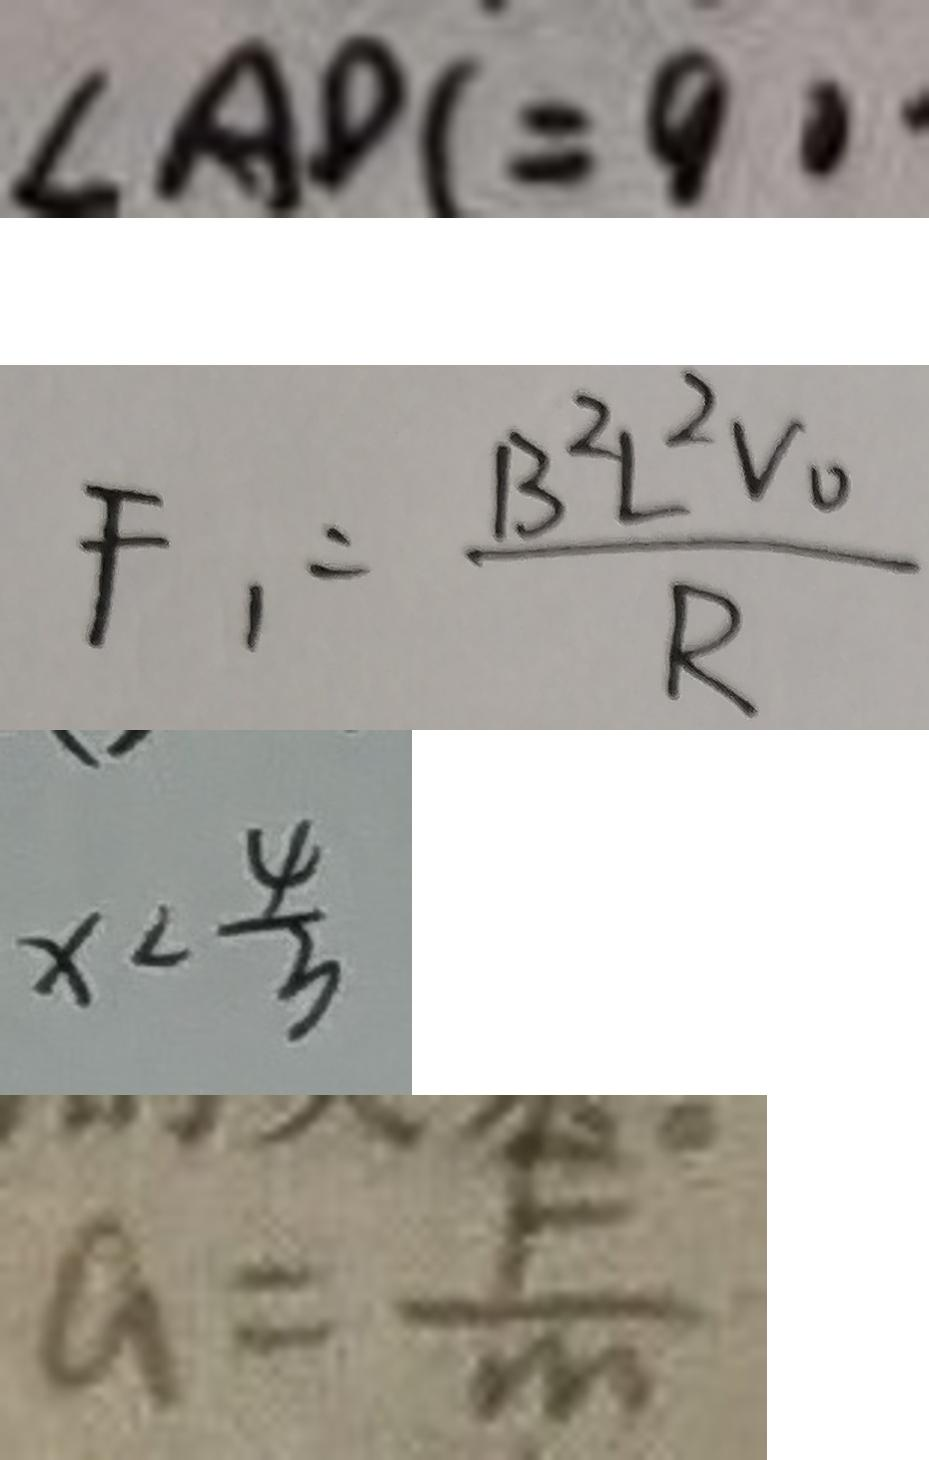Convert formula to latex. <formula><loc_0><loc_0><loc_500><loc_500>\angle A D C = 9 0 ^ { \circ } 
 F _ { 1 } = \frac { B ^ { 2 } L ^ { 2 } V _ { 0 } } { R } 
 x < \frac { 4 } { 3 } 
 a = \frac { F } { m }</formula> 